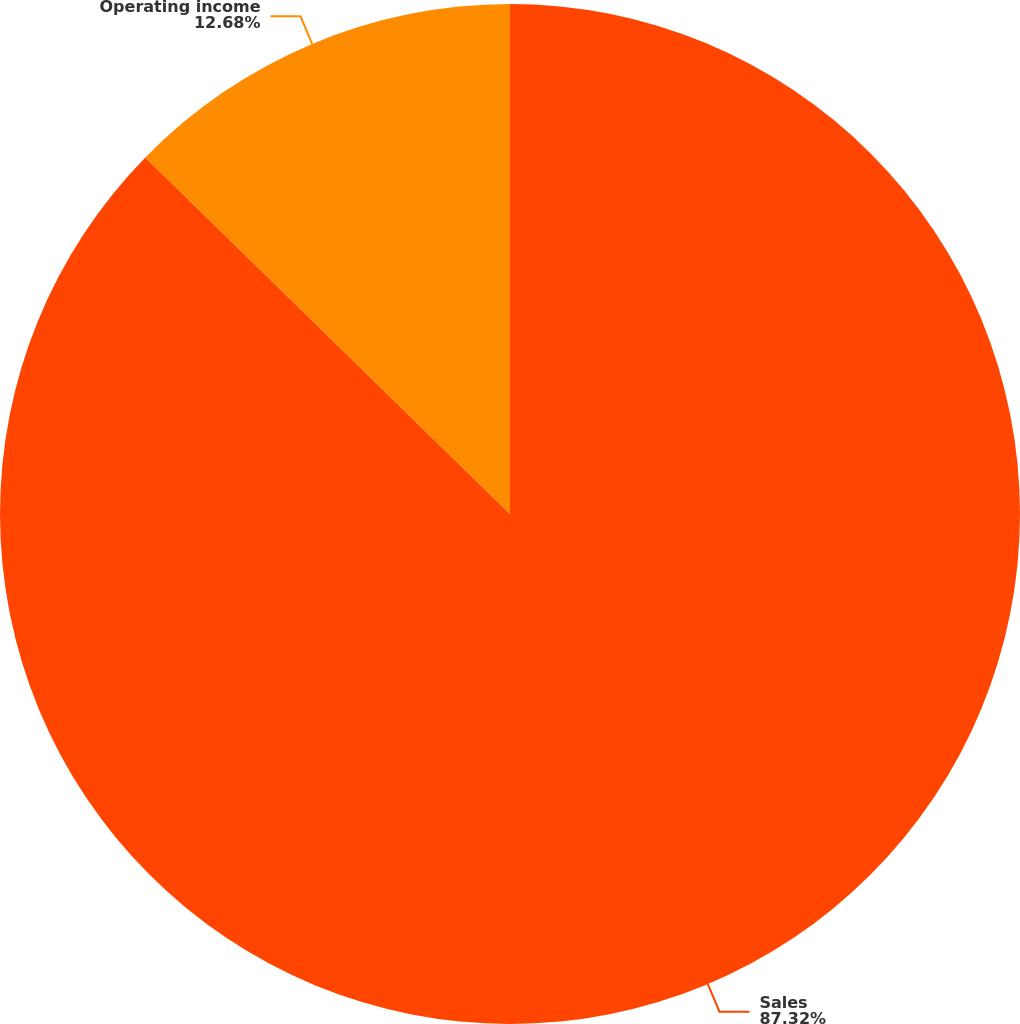Convert chart to OTSL. <chart><loc_0><loc_0><loc_500><loc_500><pie_chart><fcel>Sales<fcel>Operating income<nl><fcel>87.32%<fcel>12.68%<nl></chart> 